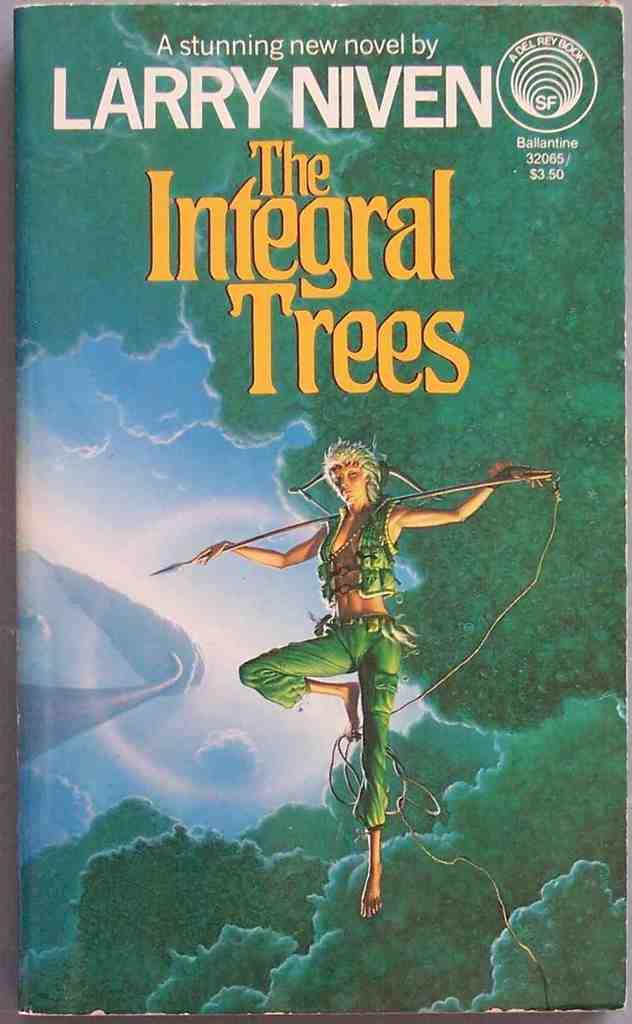What is the title of this book?
Offer a terse response. The integral trees. 